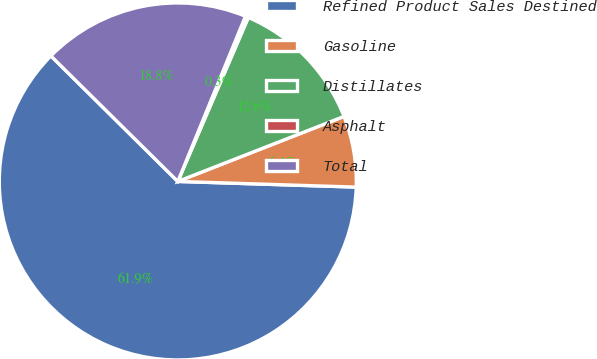Convert chart to OTSL. <chart><loc_0><loc_0><loc_500><loc_500><pie_chart><fcel>Refined Product Sales Destined<fcel>Gasoline<fcel>Distillates<fcel>Asphalt<fcel>Total<nl><fcel>61.91%<fcel>6.44%<fcel>12.6%<fcel>0.28%<fcel>18.77%<nl></chart> 